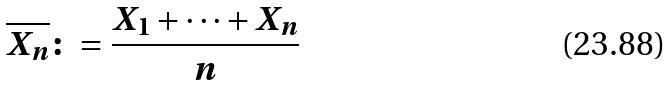<formula> <loc_0><loc_0><loc_500><loc_500>\overline { X _ { n } } \colon = \frac { X _ { 1 } + \cdot \cdot \cdot + X _ { n } } { n }</formula> 